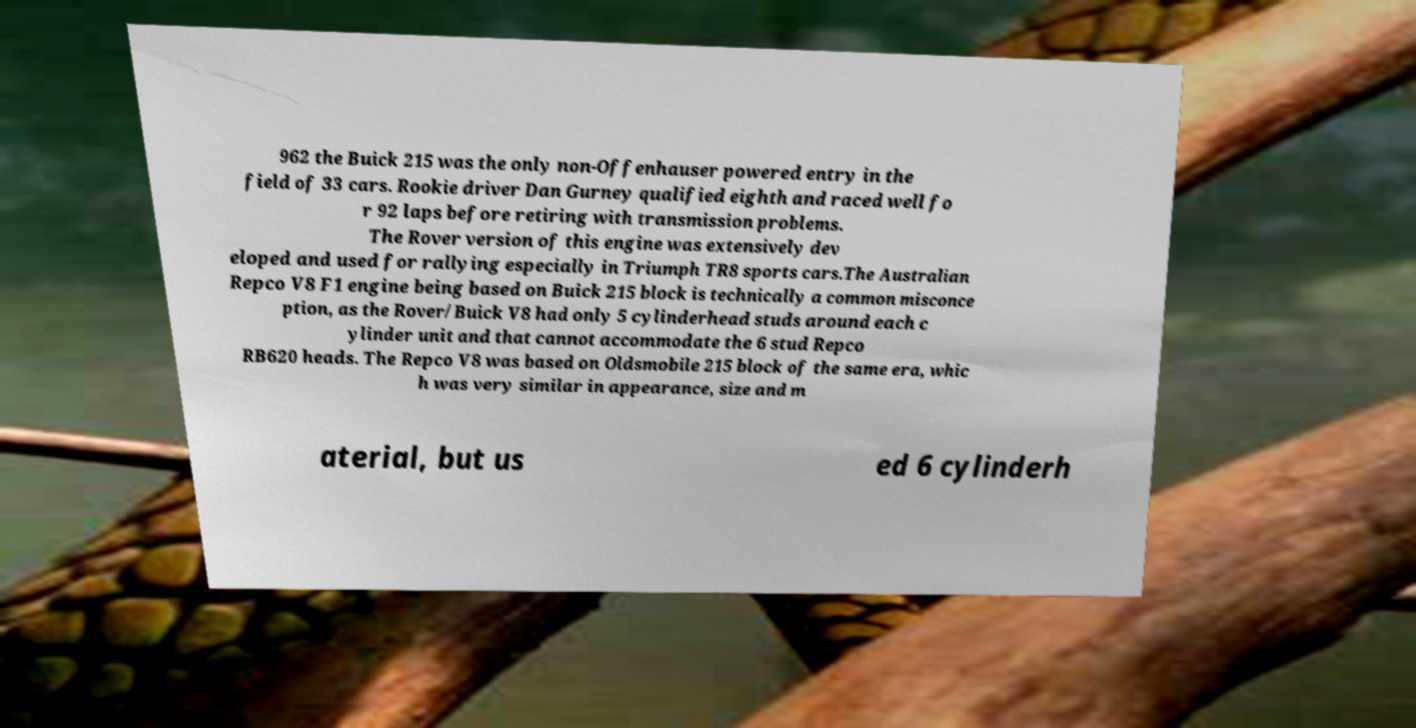Could you assist in decoding the text presented in this image and type it out clearly? 962 the Buick 215 was the only non-Offenhauser powered entry in the field of 33 cars. Rookie driver Dan Gurney qualified eighth and raced well fo r 92 laps before retiring with transmission problems. The Rover version of this engine was extensively dev eloped and used for rallying especially in Triumph TR8 sports cars.The Australian Repco V8 F1 engine being based on Buick 215 block is technically a common misconce ption, as the Rover/Buick V8 had only 5 cylinderhead studs around each c ylinder unit and that cannot accommodate the 6 stud Repco RB620 heads. The Repco V8 was based on Oldsmobile 215 block of the same era, whic h was very similar in appearance, size and m aterial, but us ed 6 cylinderh 